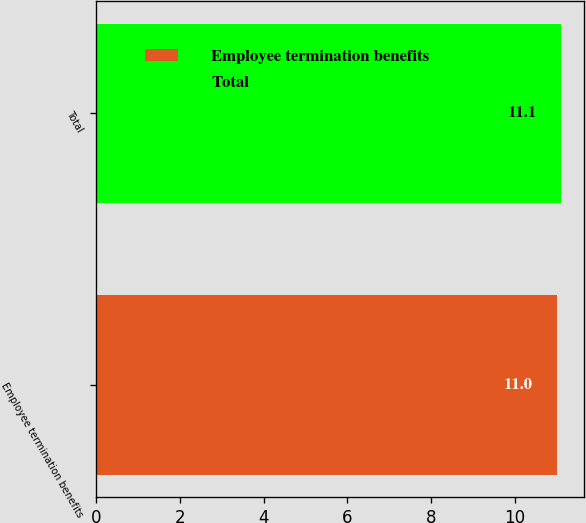<chart> <loc_0><loc_0><loc_500><loc_500><bar_chart><fcel>Employee termination benefits<fcel>Total<nl><fcel>11<fcel>11.1<nl></chart> 